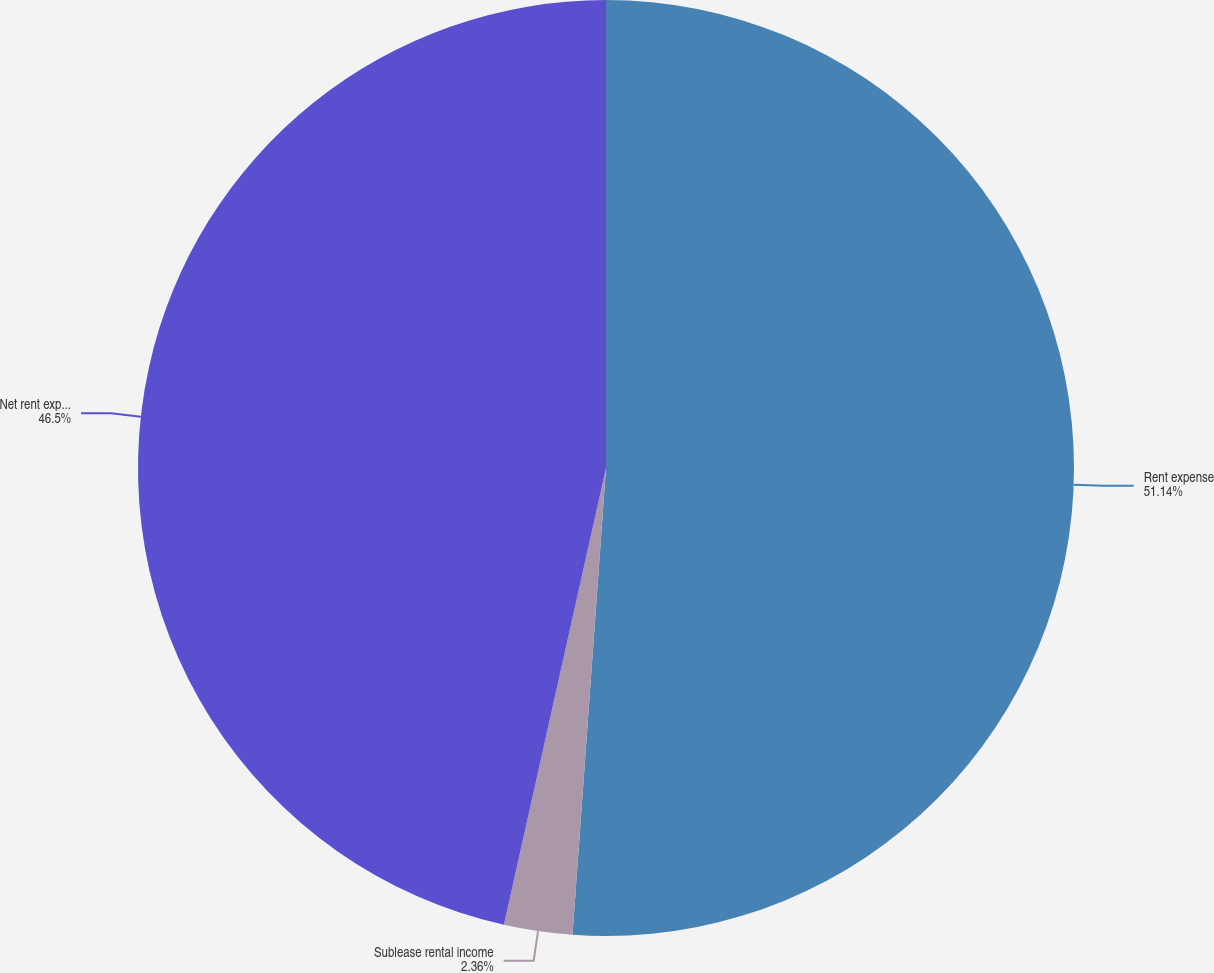Convert chart. <chart><loc_0><loc_0><loc_500><loc_500><pie_chart><fcel>Rent expense<fcel>Sublease rental income<fcel>Net rent expense<nl><fcel>51.14%<fcel>2.36%<fcel>46.5%<nl></chart> 